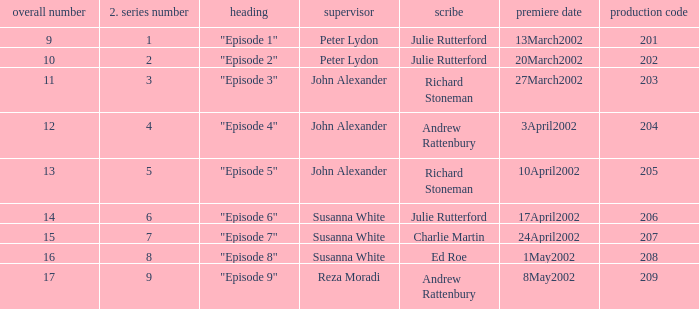Could you parse the entire table as a dict? {'header': ['overall number', '2. series number', 'heading', 'supervisor', 'scribe', 'premiere date', 'production code'], 'rows': [['9', '1', '"Episode 1"', 'Peter Lydon', 'Julie Rutterford', '13March2002', '201'], ['10', '2', '"Episode 2"', 'Peter Lydon', 'Julie Rutterford', '20March2002', '202'], ['11', '3', '"Episode 3"', 'John Alexander', 'Richard Stoneman', '27March2002', '203'], ['12', '4', '"Episode 4"', 'John Alexander', 'Andrew Rattenbury', '3April2002', '204'], ['13', '5', '"Episode 5"', 'John Alexander', 'Richard Stoneman', '10April2002', '205'], ['14', '6', '"Episode 6"', 'Susanna White', 'Julie Rutterford', '17April2002', '206'], ['15', '7', '"Episode 7"', 'Susanna White', 'Charlie Martin', '24April2002', '207'], ['16', '8', '"Episode 8"', 'Susanna White', 'Ed Roe', '1May2002', '208'], ['17', '9', '"Episode 9"', 'Reza Moradi', 'Andrew Rattenbury', '8May2002', '209']]} When "episode 1" is the title what is the overall number? 9.0. 